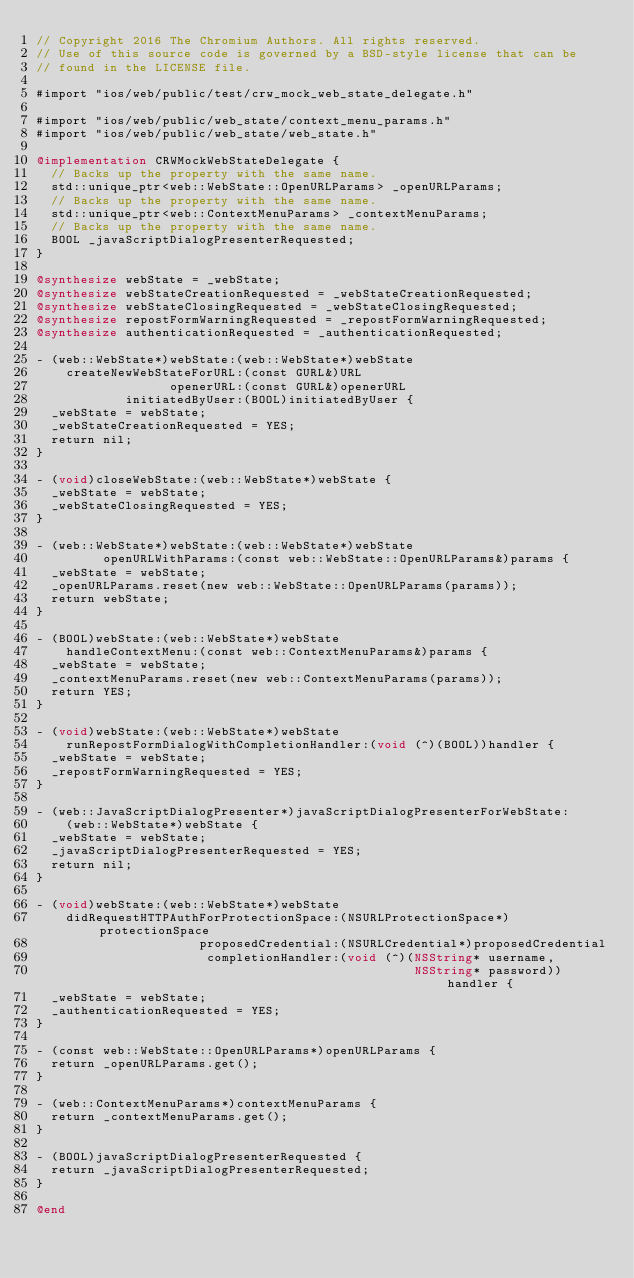<code> <loc_0><loc_0><loc_500><loc_500><_ObjectiveC_>// Copyright 2016 The Chromium Authors. All rights reserved.
// Use of this source code is governed by a BSD-style license that can be
// found in the LICENSE file.

#import "ios/web/public/test/crw_mock_web_state_delegate.h"

#import "ios/web/public/web_state/context_menu_params.h"
#import "ios/web/public/web_state/web_state.h"

@implementation CRWMockWebStateDelegate {
  // Backs up the property with the same name.
  std::unique_ptr<web::WebState::OpenURLParams> _openURLParams;
  // Backs up the property with the same name.
  std::unique_ptr<web::ContextMenuParams> _contextMenuParams;
  // Backs up the property with the same name.
  BOOL _javaScriptDialogPresenterRequested;
}

@synthesize webState = _webState;
@synthesize webStateCreationRequested = _webStateCreationRequested;
@synthesize webStateClosingRequested = _webStateClosingRequested;
@synthesize repostFormWarningRequested = _repostFormWarningRequested;
@synthesize authenticationRequested = _authenticationRequested;

- (web::WebState*)webState:(web::WebState*)webState
    createNewWebStateForURL:(const GURL&)URL
                  openerURL:(const GURL&)openerURL
            initiatedByUser:(BOOL)initiatedByUser {
  _webState = webState;
  _webStateCreationRequested = YES;
  return nil;
}

- (void)closeWebState:(web::WebState*)webState {
  _webState = webState;
  _webStateClosingRequested = YES;
}

- (web::WebState*)webState:(web::WebState*)webState
         openURLWithParams:(const web::WebState::OpenURLParams&)params {
  _webState = webState;
  _openURLParams.reset(new web::WebState::OpenURLParams(params));
  return webState;
}

- (BOOL)webState:(web::WebState*)webState
    handleContextMenu:(const web::ContextMenuParams&)params {
  _webState = webState;
  _contextMenuParams.reset(new web::ContextMenuParams(params));
  return YES;
}

- (void)webState:(web::WebState*)webState
    runRepostFormDialogWithCompletionHandler:(void (^)(BOOL))handler {
  _webState = webState;
  _repostFormWarningRequested = YES;
}

- (web::JavaScriptDialogPresenter*)javaScriptDialogPresenterForWebState:
    (web::WebState*)webState {
  _webState = webState;
  _javaScriptDialogPresenterRequested = YES;
  return nil;
}

- (void)webState:(web::WebState*)webState
    didRequestHTTPAuthForProtectionSpace:(NSURLProtectionSpace*)protectionSpace
                      proposedCredential:(NSURLCredential*)proposedCredential
                       completionHandler:(void (^)(NSString* username,
                                                   NSString* password))handler {
  _webState = webState;
  _authenticationRequested = YES;
}

- (const web::WebState::OpenURLParams*)openURLParams {
  return _openURLParams.get();
}

- (web::ContextMenuParams*)contextMenuParams {
  return _contextMenuParams.get();
}

- (BOOL)javaScriptDialogPresenterRequested {
  return _javaScriptDialogPresenterRequested;
}

@end
</code> 